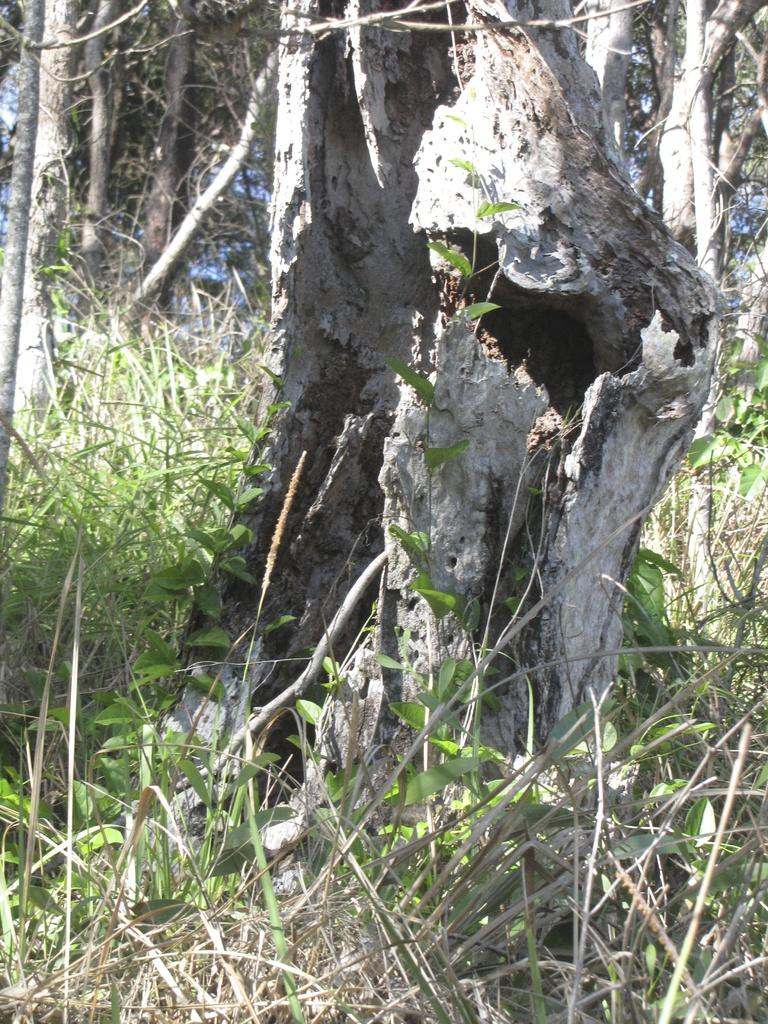What type of vegetation is at the bottom of the image? There is grass at the bottom of the image. What part of a tree is visible in the middle of the image? The stem of a tree is visible in the middle of the image. What can be seen in the background of the image? There are trees in the background of the image. How many development projects are visible in the image? There is no mention of development projects in the image; it primarily features vegetation. Can you describe the lamp that is illuminating the trees in the image? There is no lamp present in the image; it only features trees and vegetation. 